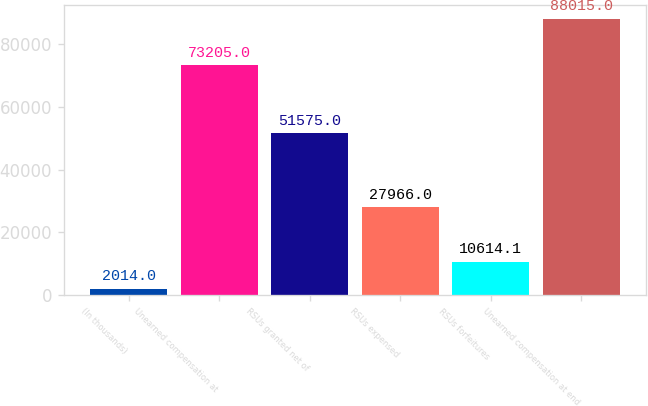Convert chart to OTSL. <chart><loc_0><loc_0><loc_500><loc_500><bar_chart><fcel>(In thousands)<fcel>Unearned compensation at<fcel>RSUs granted net of<fcel>RSUs expensed<fcel>RSUs forfeitures<fcel>Unearned compensation at end<nl><fcel>2014<fcel>73205<fcel>51575<fcel>27966<fcel>10614.1<fcel>88015<nl></chart> 